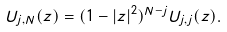Convert formula to latex. <formula><loc_0><loc_0><loc_500><loc_500>U _ { j , N } ( z ) = ( 1 - | z | ^ { 2 } ) ^ { N - j } U _ { j , j } ( z ) .</formula> 